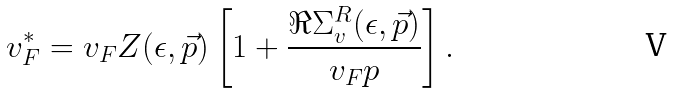Convert formula to latex. <formula><loc_0><loc_0><loc_500><loc_500>v _ { F } ^ { * } = v _ { F } Z ( \epsilon , \vec { p } ) \left [ 1 + \frac { \Re \Sigma ^ { R } _ { v } ( \epsilon , \vec { p } ) } { v _ { F } p } \right ] .</formula> 